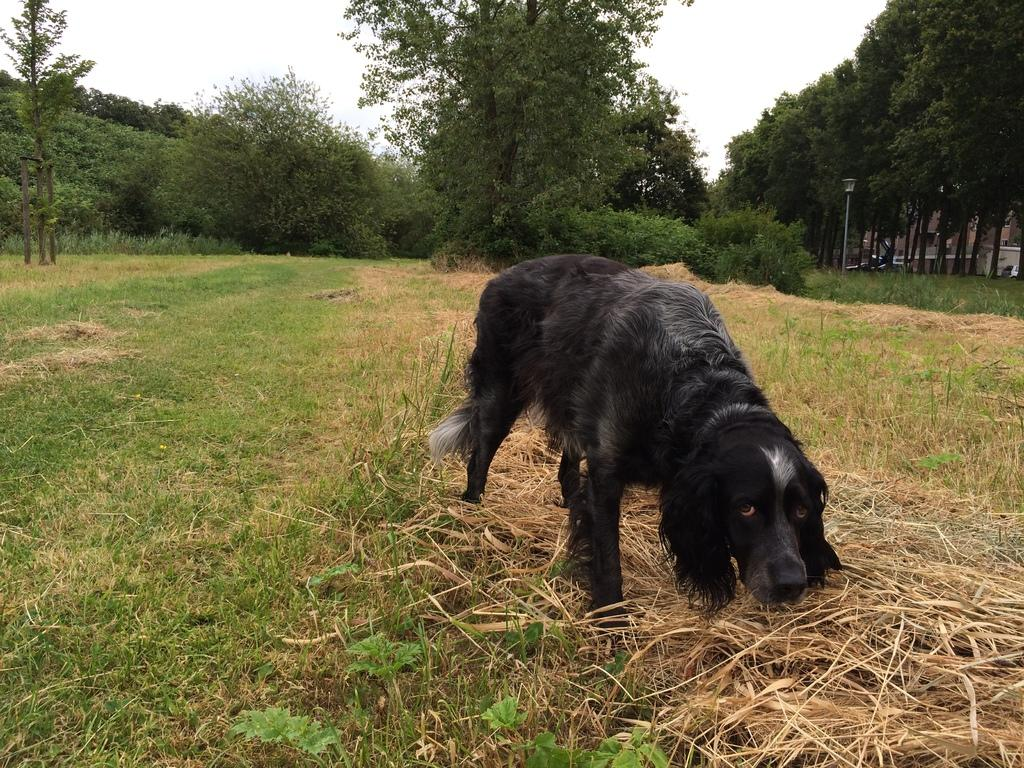What animal can be seen in the image? There is a dog in the image. Where is the dog located? The dog is on a grassland. What can be seen in the background of the image? There are trees and the sky visible in the background of the image. What type of system is the dog using to dig in the middle of the image? There is no system or digging activity present in the image; the dog is simply standing on a grassland. 